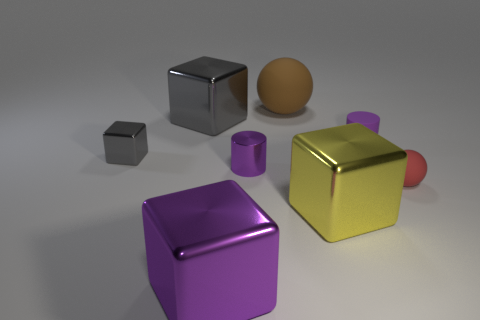There is a large shiny object that is the same color as the small matte cylinder; what shape is it?
Offer a terse response. Cube. Do the cylinder that is left of the large brown matte thing and the tiny rubber cylinder have the same color?
Offer a very short reply. Yes. What number of spheres are big brown things or yellow metal things?
Provide a succinct answer. 1. What shape is the matte object behind the purple rubber cylinder?
Provide a short and direct response. Sphere. There is a matte sphere in front of the gray shiny block that is in front of the tiny matte object that is behind the purple metal cylinder; what color is it?
Provide a succinct answer. Red. Are the brown ball and the large yellow thing made of the same material?
Give a very brief answer. No. What number of gray things are small rubber objects or small cylinders?
Keep it short and to the point. 0. How many shiny blocks are on the left side of the big yellow metallic cube?
Your response must be concise. 3. Is the number of gray blocks greater than the number of tiny brown things?
Provide a succinct answer. Yes. What is the shape of the small purple object behind the gray shiny object in front of the purple rubber cylinder?
Your answer should be very brief. Cylinder. 